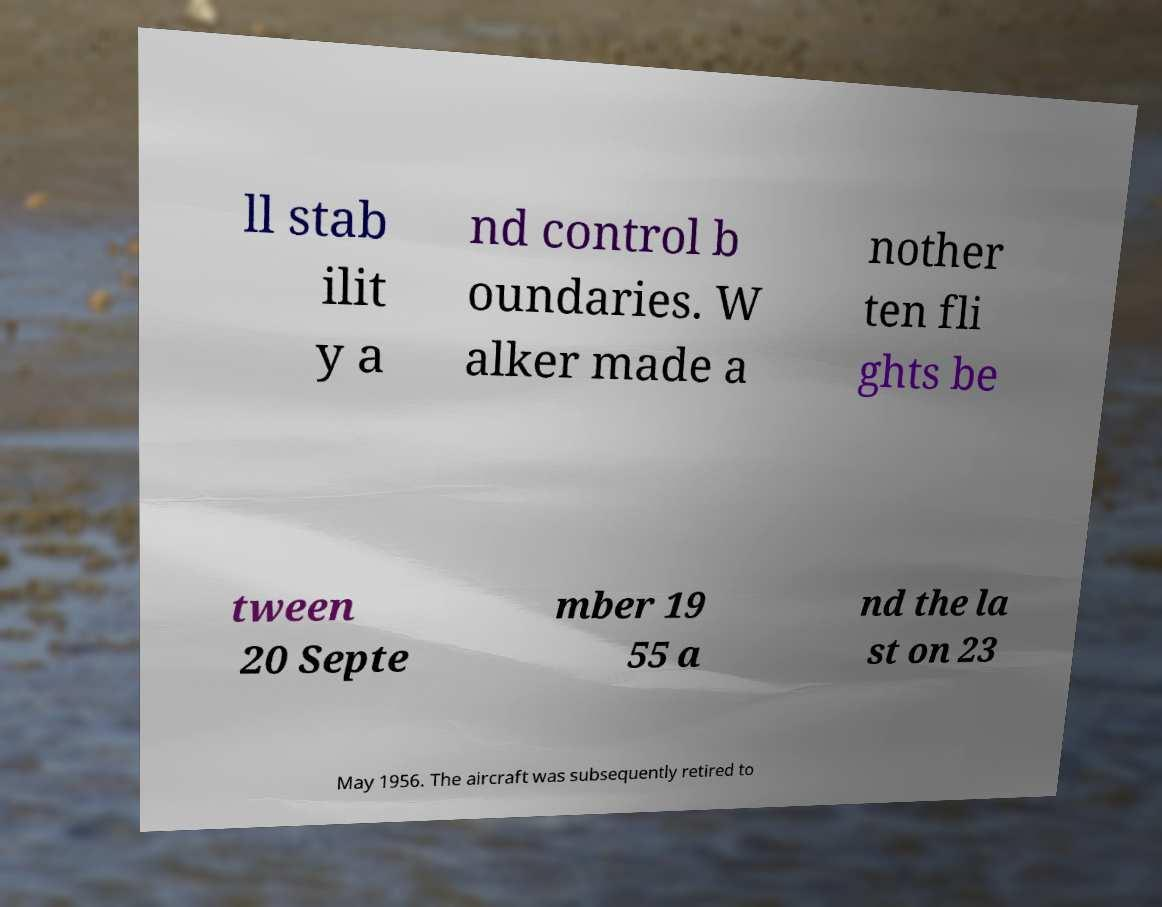Please identify and transcribe the text found in this image. ll stab ilit y a nd control b oundaries. W alker made a nother ten fli ghts be tween 20 Septe mber 19 55 a nd the la st on 23 May 1956. The aircraft was subsequently retired to 